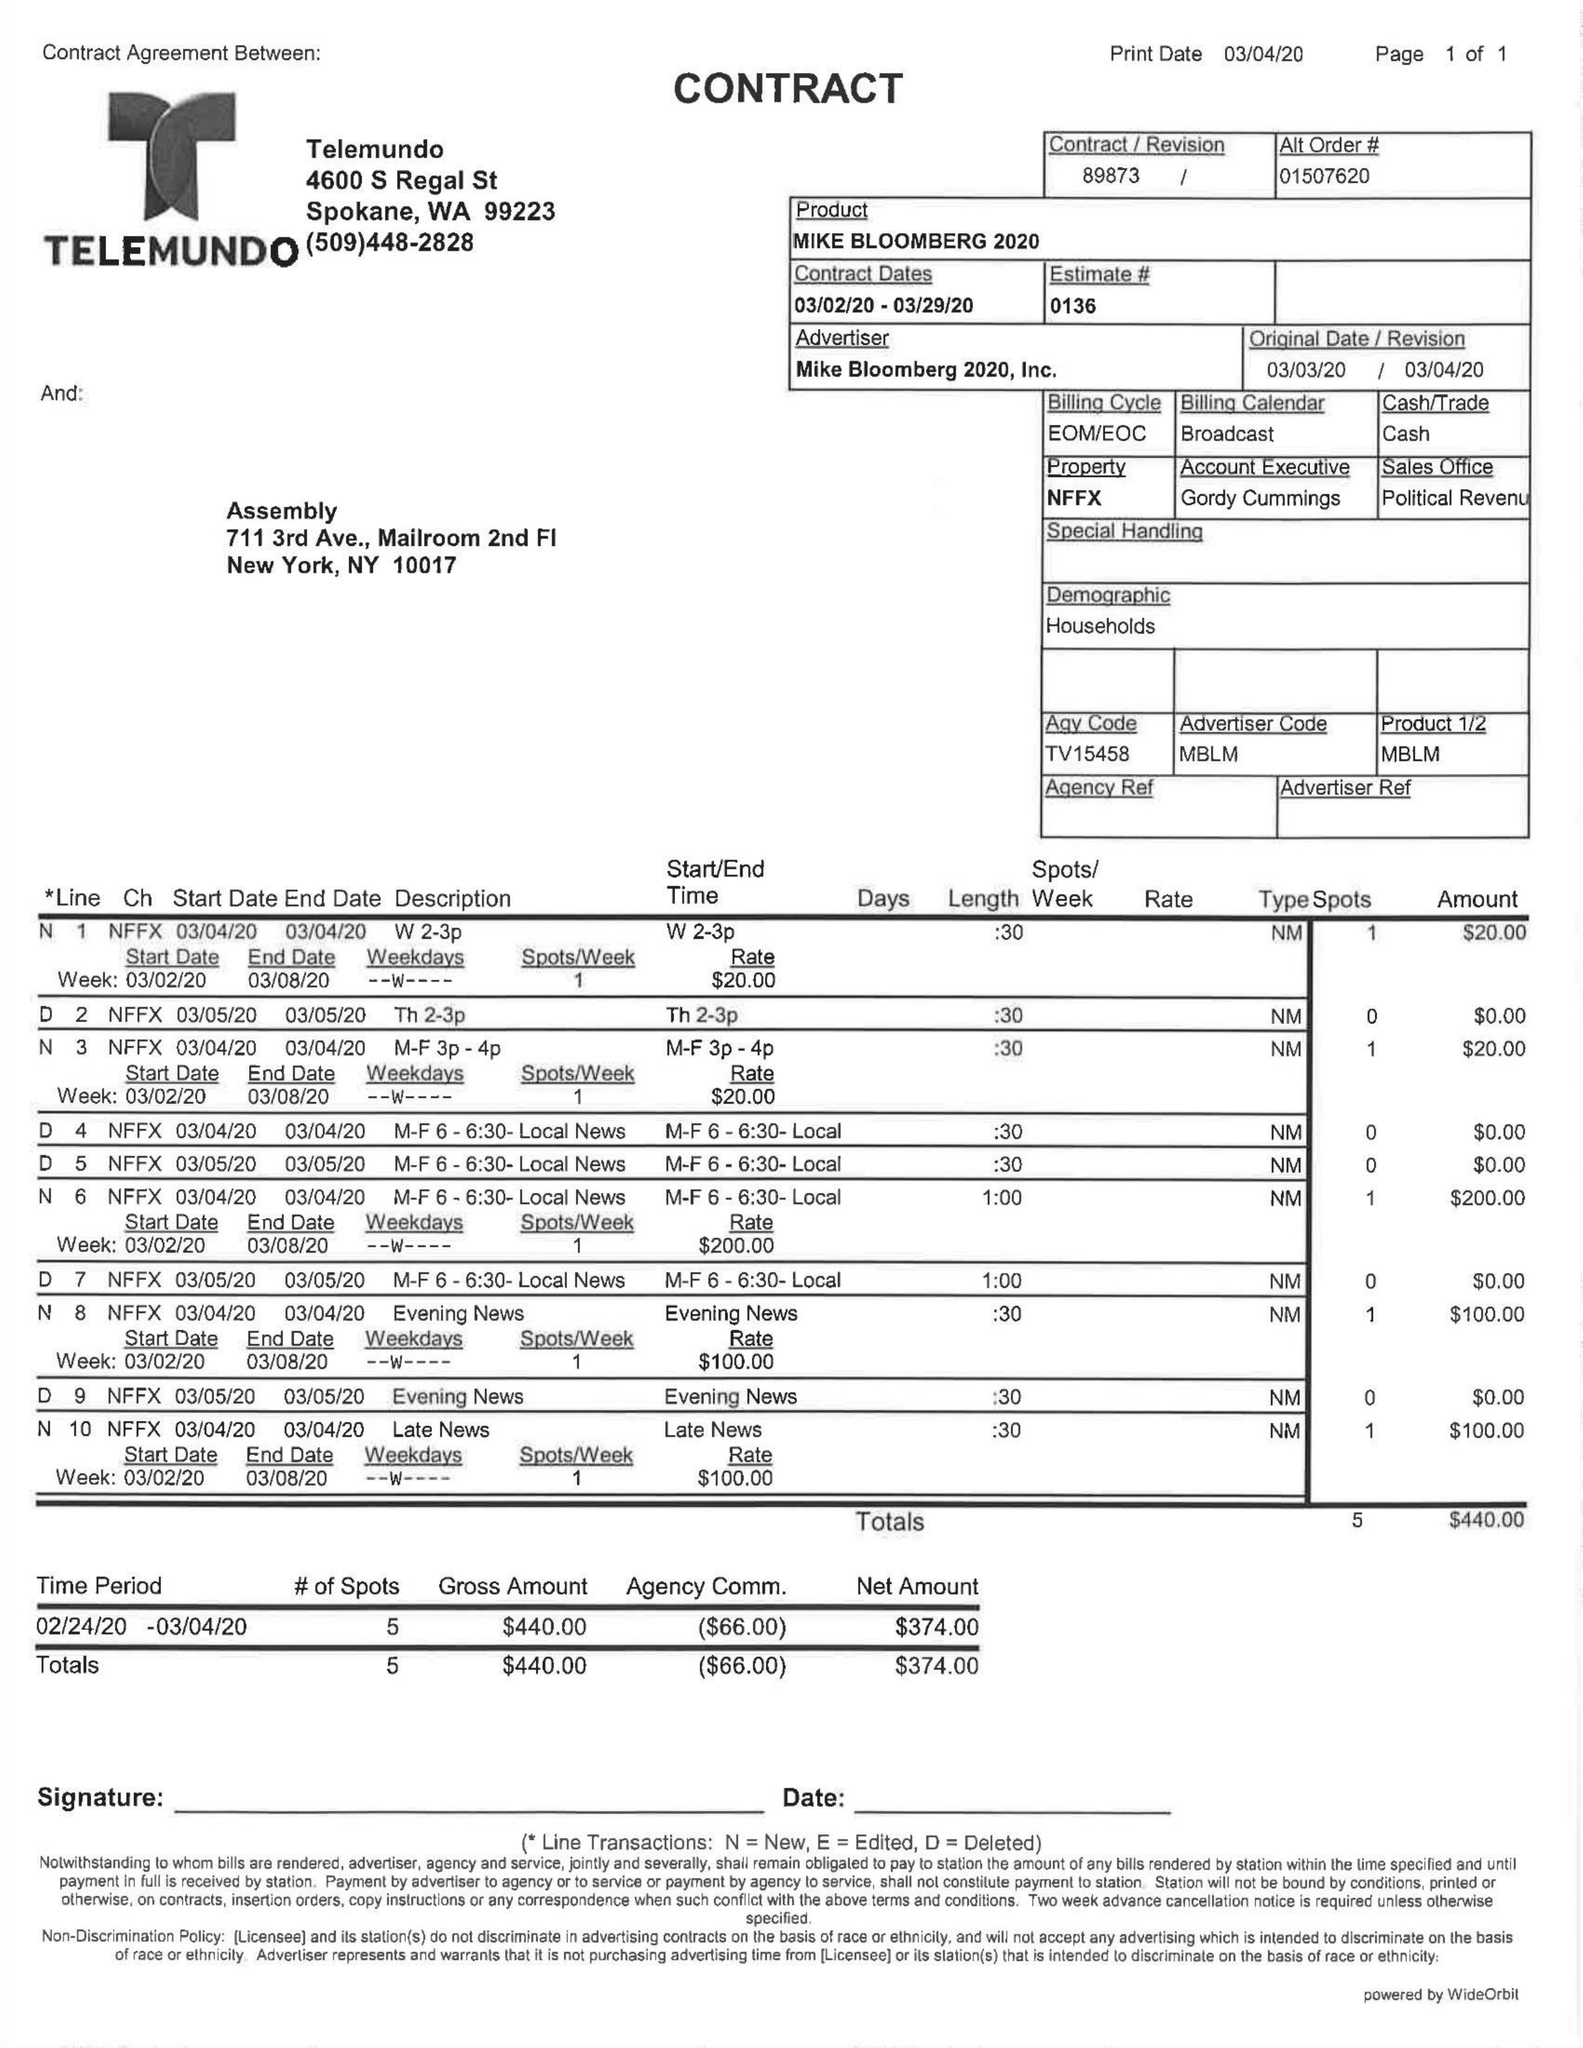What is the value for the flight_from?
Answer the question using a single word or phrase. 03/02/20 